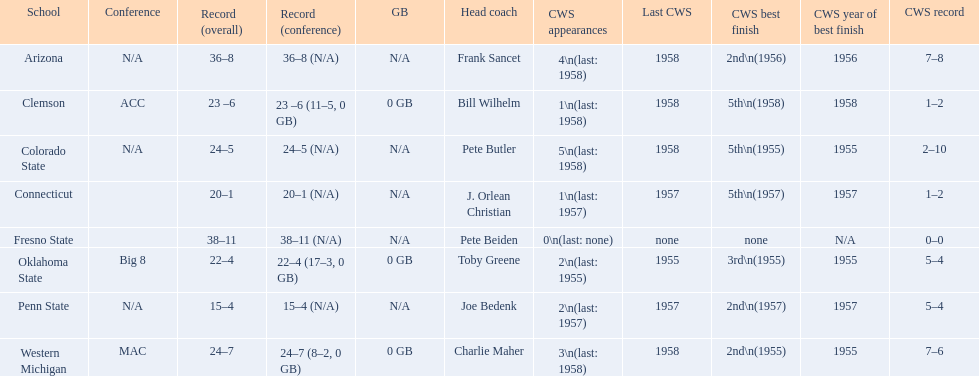What are the number of schools with more than 2 cws appearances? 3. 